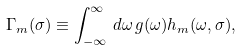<formula> <loc_0><loc_0><loc_500><loc_500>\Gamma _ { m } ( \sigma ) \equiv \int _ { - \infty } ^ { \infty } \, d \omega \, g ( \omega ) h _ { m } ( \omega , \sigma ) ,</formula> 